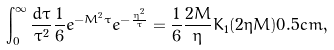<formula> <loc_0><loc_0><loc_500><loc_500>\int _ { 0 } ^ { \infty } \frac { d \tau } { \tau ^ { 2 } } \frac { 1 } { 6 } e ^ { - M ^ { 2 } \tau } e ^ { - \frac { \eta ^ { 2 } } { \tau } } = \frac { 1 } { 6 } \frac { 2 M } { \eta } K _ { 1 } ( 2 \eta M ) 0 . 5 c m ,</formula> 